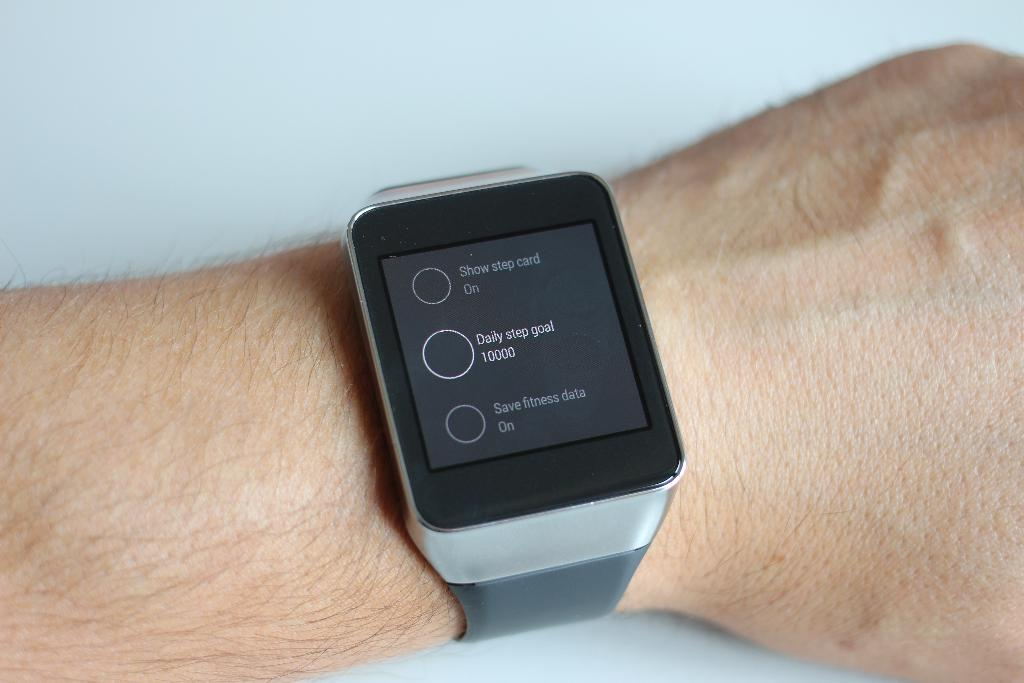<image>
Offer a succinct explanation of the picture presented. a watch that has a daily step goal on it 